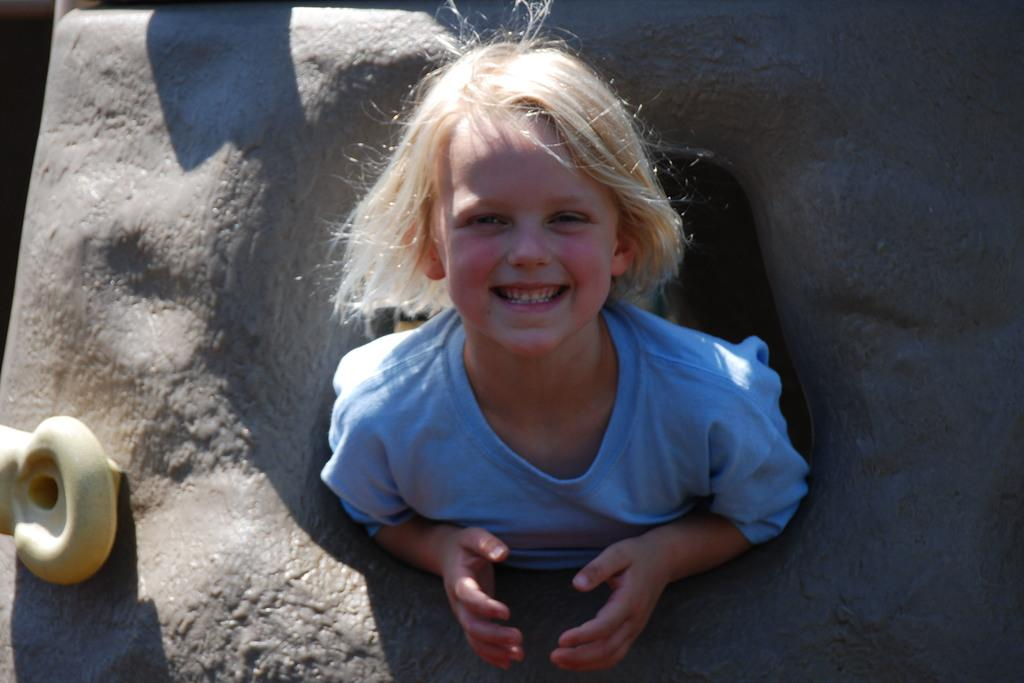Who is present in the image? There is a girl in the image. What is the girl's expression in the image? The girl is smiling in the image. What else can be seen in the image besides the girl? There are objects in the image. What type of robin can be seen in the girl's mind in the image? There is no robin present in the image, and the girl's thoughts or mind are not visible. 